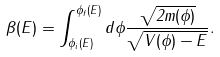<formula> <loc_0><loc_0><loc_500><loc_500>\beta ( E ) = \int _ { \phi _ { i } ( E ) } ^ { \phi _ { f } ( E ) } d \phi \frac { \sqrt { 2 m ( \phi ) } } { \sqrt { V ( \phi ) - E } } .</formula> 